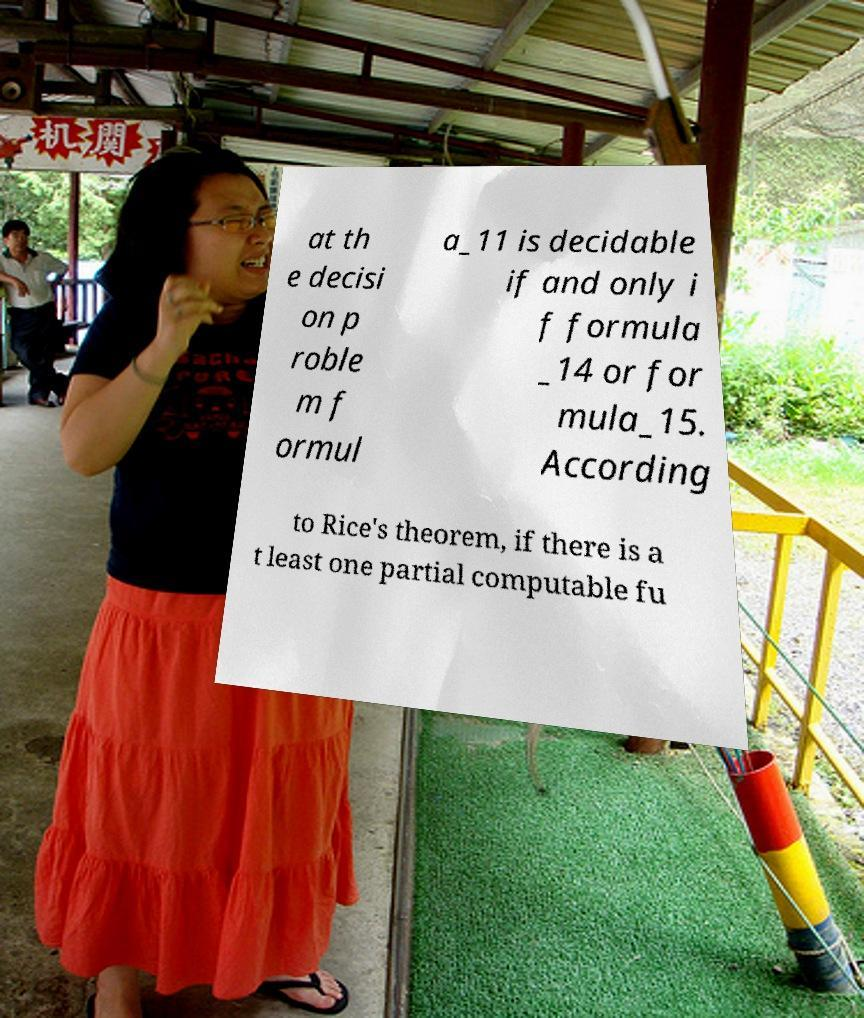Can you read and provide the text displayed in the image?This photo seems to have some interesting text. Can you extract and type it out for me? at th e decisi on p roble m f ormul a_11 is decidable if and only i f formula _14 or for mula_15. According to Rice's theorem, if there is a t least one partial computable fu 